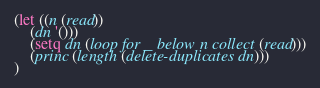Convert code to text. <code><loc_0><loc_0><loc_500><loc_500><_Lisp_>(let ((n (read))
    (dn '()))
    (setq dn (loop for _ below n collect (read)))
    (princ (length (delete-duplicates dn))) 
)</code> 